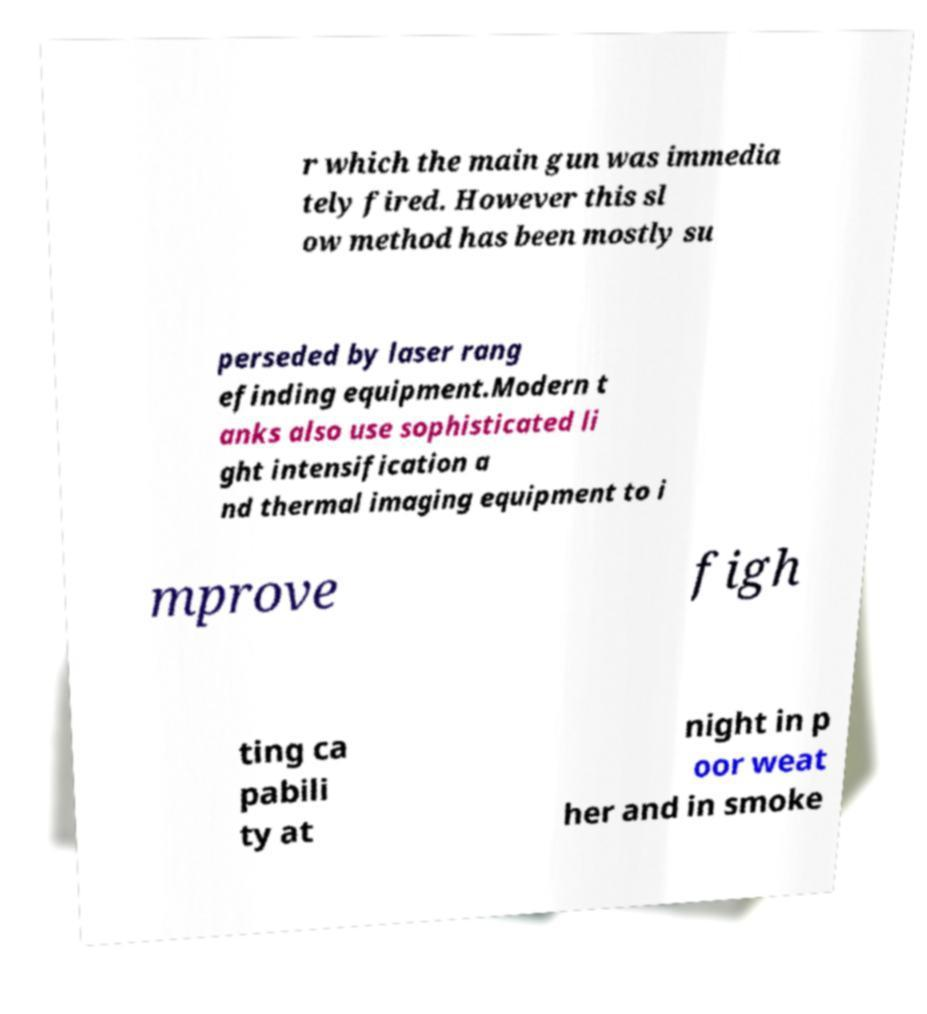Please read and relay the text visible in this image. What does it say? r which the main gun was immedia tely fired. However this sl ow method has been mostly su perseded by laser rang efinding equipment.Modern t anks also use sophisticated li ght intensification a nd thermal imaging equipment to i mprove figh ting ca pabili ty at night in p oor weat her and in smoke 